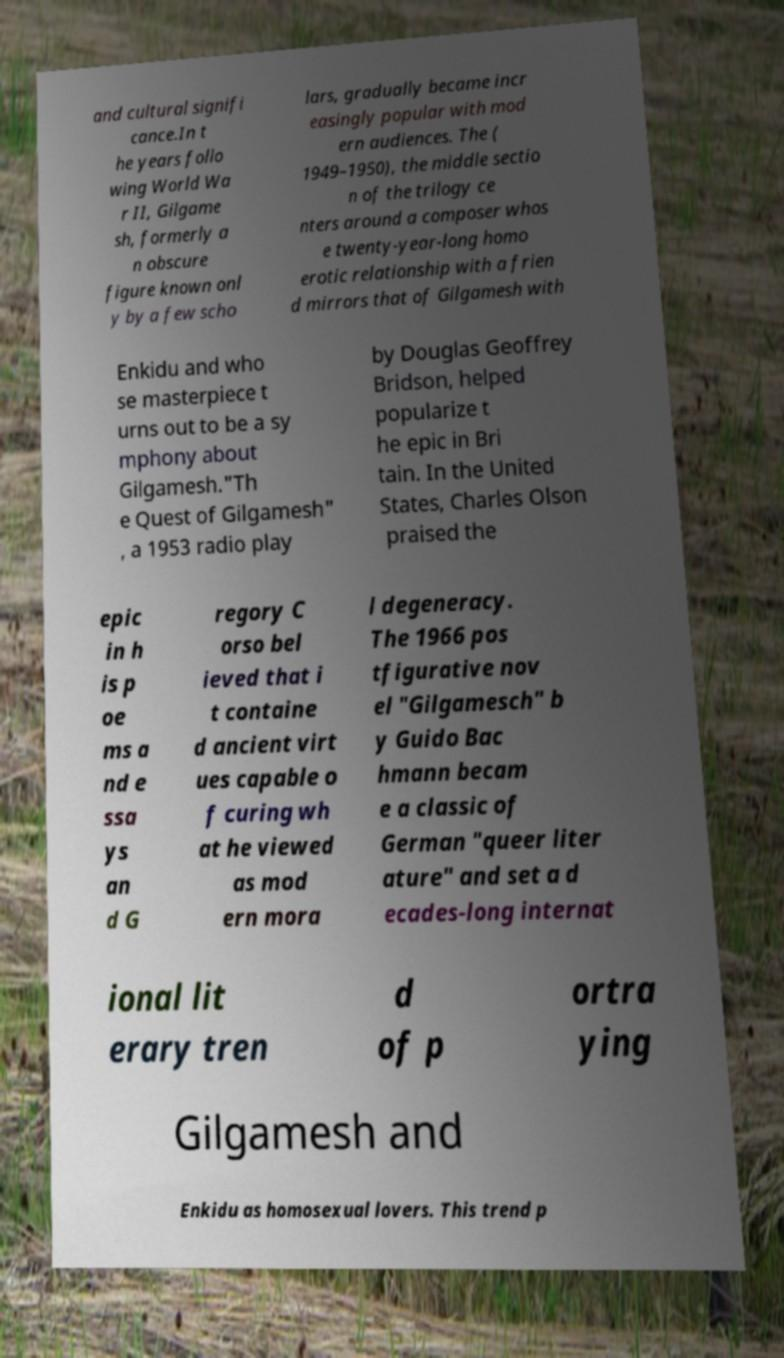I need the written content from this picture converted into text. Can you do that? and cultural signifi cance.In t he years follo wing World Wa r II, Gilgame sh, formerly a n obscure figure known onl y by a few scho lars, gradually became incr easingly popular with mod ern audiences. The ( 1949–1950), the middle sectio n of the trilogy ce nters around a composer whos e twenty-year-long homo erotic relationship with a frien d mirrors that of Gilgamesh with Enkidu and who se masterpiece t urns out to be a sy mphony about Gilgamesh."Th e Quest of Gilgamesh" , a 1953 radio play by Douglas Geoffrey Bridson, helped popularize t he epic in Bri tain. In the United States, Charles Olson praised the epic in h is p oe ms a nd e ssa ys an d G regory C orso bel ieved that i t containe d ancient virt ues capable o f curing wh at he viewed as mod ern mora l degeneracy. The 1966 pos tfigurative nov el "Gilgamesch" b y Guido Bac hmann becam e a classic of German "queer liter ature" and set a d ecades-long internat ional lit erary tren d of p ortra ying Gilgamesh and Enkidu as homosexual lovers. This trend p 